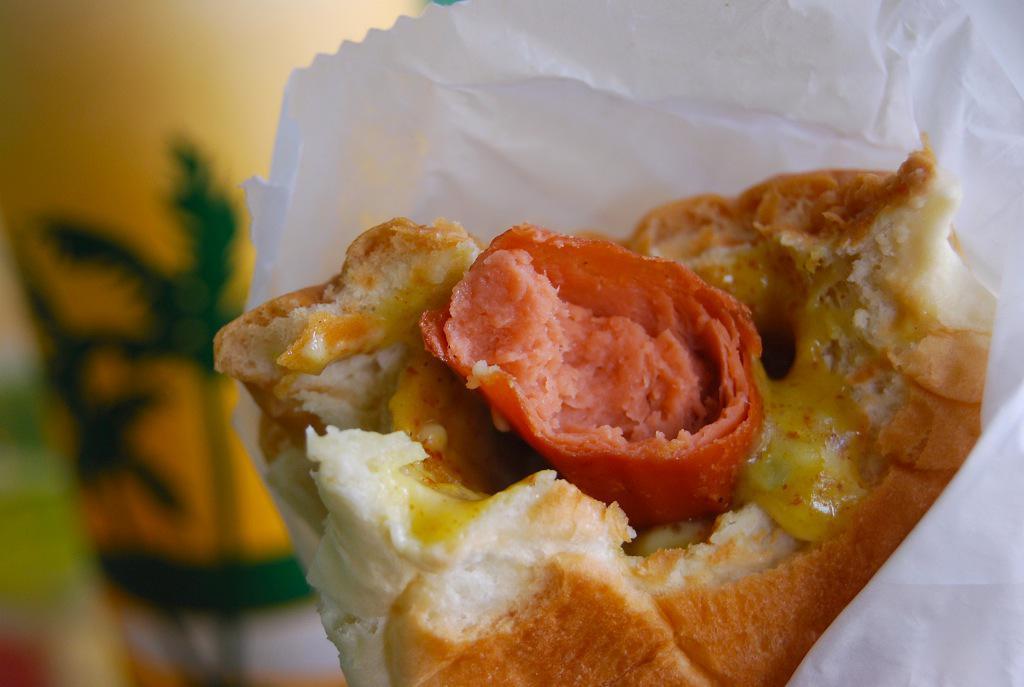In one or two sentences, can you explain what this image depicts? There is a food item with sausage and some other things. It is in a white paper. In the back it is blurred and there is a yellow and green color object. 